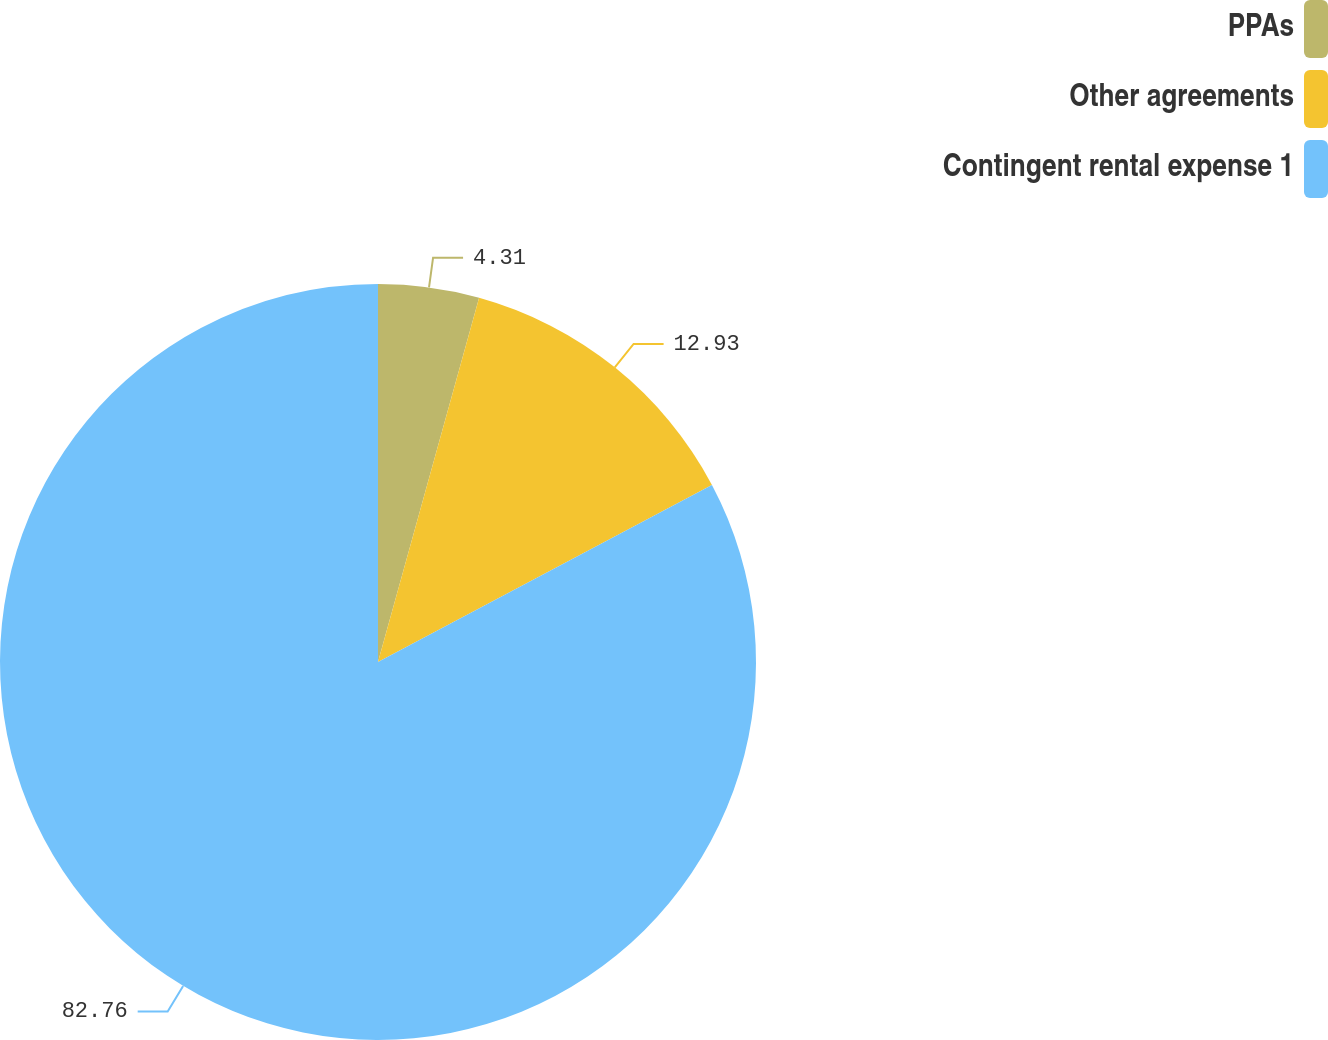Convert chart. <chart><loc_0><loc_0><loc_500><loc_500><pie_chart><fcel>PPAs<fcel>Other agreements<fcel>Contingent rental expense 1<nl><fcel>4.31%<fcel>12.93%<fcel>82.76%<nl></chart> 